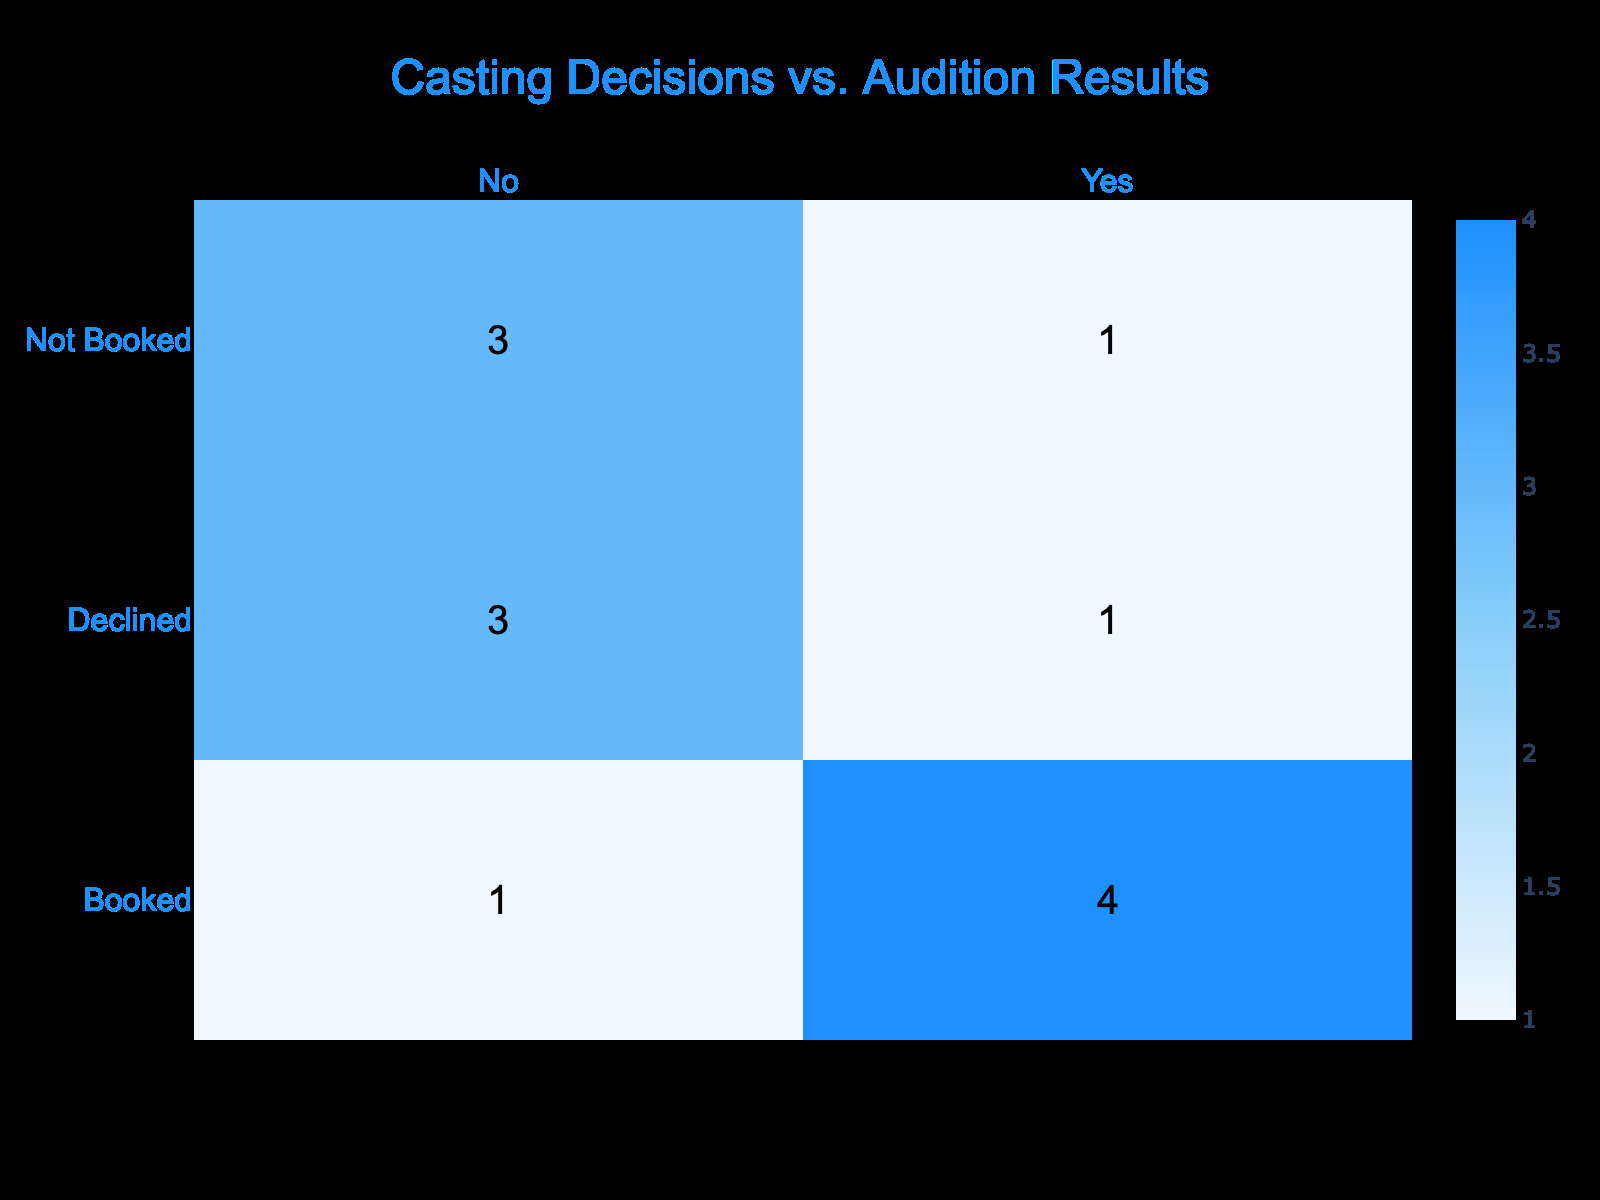What is the total number of auditions that resulted in a 'Booked' outcome? To find the total number of 'Booked' outcomes, I will look at the values in the 'Audition Result' row under the 'Booked' category. There are four instances of 'Booked', which means the total number is 4.
Answer: 4 How many total casting decisions were made that resulted in 'Yes'? I need to count how many 'Yes' decisions are under both 'Booked' and 'Declined' outcomes in the 'Casting Decision' column. There are three 'Yes' decisions for 'Booked' and one for 'Declined', totaling 4.
Answer: 4 What percentage of auditions were declined? To calculate the percentage of declined auditions, I will first count the total number of auditions (13) and then count the declined ones (3). To find the percentage: (3/13) * 100 = 23.08%.
Answer: 23.08% Was there any instance where a 'Declined' audition led to a 'Yes' casting decision? By inspecting the table, I see that all 'Declined' outcomes have a 'No' casting decision associated with them. Therefore, the answer to this question is no.
Answer: No What is the difference in the number of 'Not Booked' auditions compared to 'Booked' auditions? I need to count 'Not Booked' (5) and 'Booked' (4). The difference is 5 - 4 = 1.
Answer: 1 How many auditions resulted in both 'Booked' and 'Yes'? By looking at the 'Booked' results first, I can find that there are four 'Booked' outcomes, and all four of them correspond to 'Yes' in casting decisions. Therefore, the answer is 4.
Answer: 4 If we consider all casting decisions, what is the ratio of 'No' to 'Yes' decisions? I will count the total number of 'No' decisions (6) and 'Yes' decisions (4). The ratio of 'No' to 'Yes' decisions is 6:4, which can be simplified to 3:2.
Answer: 3:2 What are the total counts of 'Booked' against 'Not Booked'? To conclude the counts, I will check the total counts for 'Booked' (4) and 'Not Booked' (5). Therefore, counts sum up to 4 'Booked' and 5 'Not Booked', which gives totals of 4 to 5.
Answer: 4 to 5 Are there more 'Not Booked' outcomes than 'Declined' outcomes in the auditions? Counting the outcomes reveals 5 'Not Booked' and 3 'Declined'. Since 5 is greater than 3, it confirms that there are more 'Not Booked' outcomes than 'Declined'.
Answer: Yes 